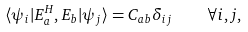<formula> <loc_0><loc_0><loc_500><loc_500>\langle \psi _ { i } | E _ { a } ^ { H } , E _ { b } | \psi _ { j } \rangle = C _ { a b } \delta _ { i j } \quad \forall i , j ,</formula> 